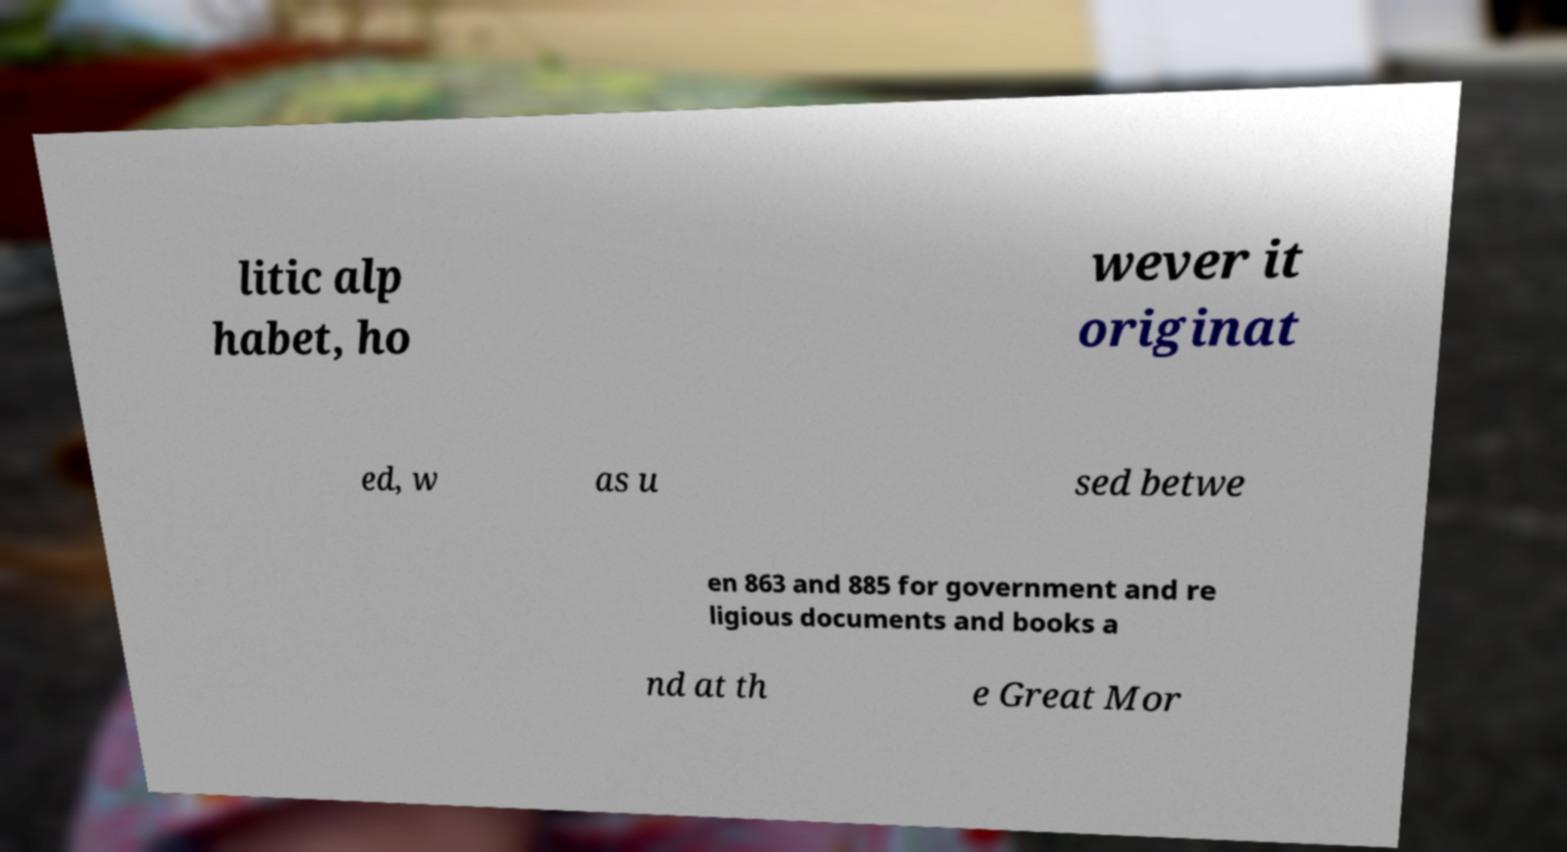I need the written content from this picture converted into text. Can you do that? litic alp habet, ho wever it originat ed, w as u sed betwe en 863 and 885 for government and re ligious documents and books a nd at th e Great Mor 